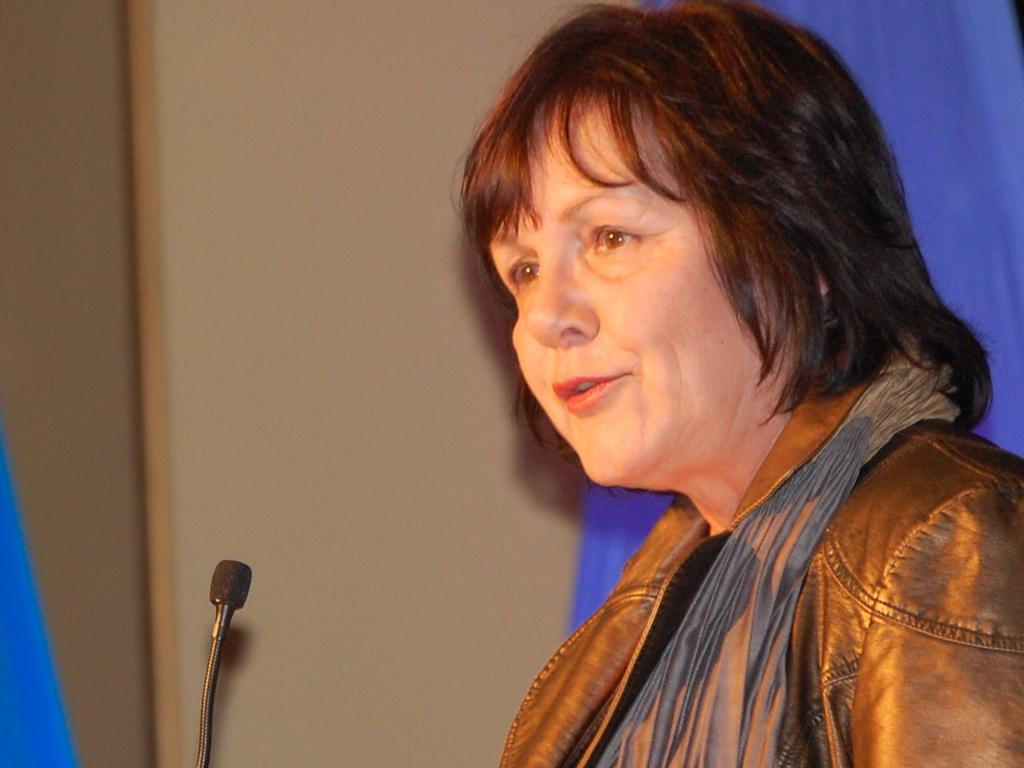Who is the main subject in the image? There is a woman in the image. What object is visible in the image that is typically used for amplifying sound? There is a microphone in the image. Can you describe any other objects present in the image? There are other objects in the image, but their specific details are not mentioned in the provided facts. Who is the owner of the event in the image? There is no information about an event or its owner in the image. How many fifth objects can be seen in the image? There is no mention of any "fifth" objects in the image, so it is impossible to answer this question. 